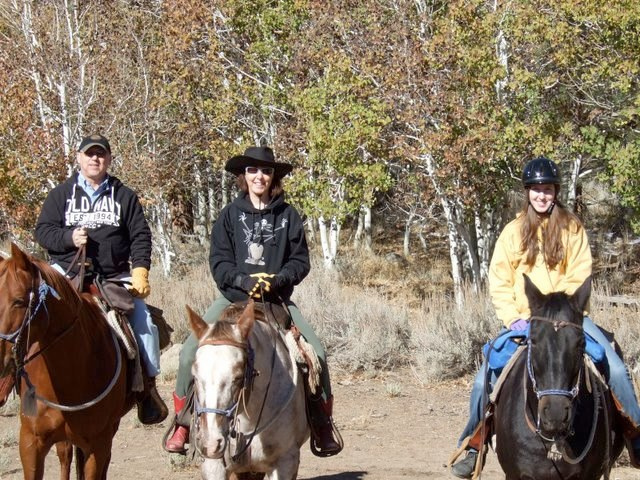Can you describe the horses and what they might be bred for? From the image, there are three horses of different colors and markings, which might suggest diverse breeds. These look like sturdier breeds suitable for trail riding, as opposed to thoroughbred horses that are bred for racing. Such breeds may include Quarter Horses known for their agility and calm disposition, which make them excellent for various riding activities. 